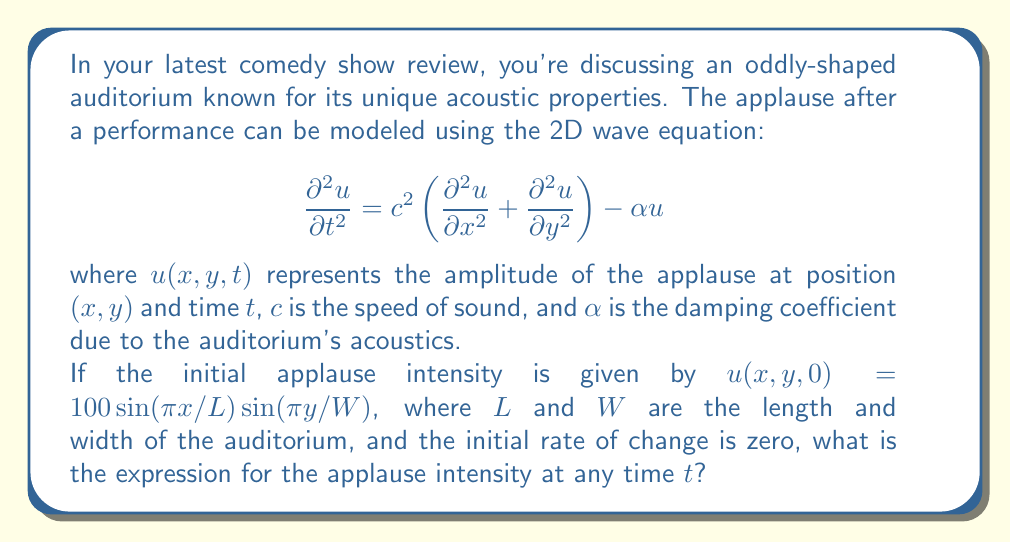Could you help me with this problem? To solve this problem, we'll follow these steps:

1) The given wave equation is a damped wave equation due to the $-\alpha u$ term.

2) We need to find a solution that satisfies the initial conditions:
   $u(x,y,0) = 100 \sin(\pi x/L) \sin(\pi y/W)$
   $\frac{\partial u}{\partial t}(x,y,0) = 0$

3) The general solution for such a damped wave equation is of the form:
   $u(x,y,t) = X(x)Y(y)T(t)$

4) Substituting this into the wave equation and separating variables, we get:
   $$\frac{T''}{T} = c^2 \left(\frac{X''}{X} + \frac{Y''}{Y}\right) - \alpha = -\omega^2$$

   Where $\omega^2$ is a separation constant.

5) This leads to three separate equations:
   $X'' + k_x^2 X = 0$
   $Y'' + k_y^2 Y = 0$
   $T'' + (\omega^2 - \alpha)T = 0$

   Where $c^2(k_x^2 + k_y^2) = \omega^2$

6) Given the initial condition, we can deduce:
   $X(x) = \sin(\pi x/L)$, so $k_x = \pi/L$
   $Y(y) = \sin(\pi y/W)$, so $k_y = \pi/W$

7) Therefore, $\omega^2 = c^2\pi^2(\frac{1}{L^2} + \frac{1}{W^2})$

8) The solution for T(t) is:
   $T(t) = e^{-\alpha t/2}(A \cos(\beta t) + B \sin(\beta t))$
   Where $\beta = \sqrt{\omega^2 - \frac{\alpha^2}{4}}$

9) Using the initial conditions:
   $T(0) = 100$, so $A = 100$
   $T'(0) = 0$, so $B = \frac{\alpha}{2\beta} A = \frac{50\alpha}{\beta}$

10) Therefore, the complete solution is:
    $$u(x,y,t) = 100 e^{-\alpha t/2} \left(\cos(\beta t) + \frac{\alpha}{2\beta} \sin(\beta t)\right) \sin(\pi x/L) \sin(\pi y/W)$$
Answer: $100 e^{-\alpha t/2} (\cos(\beta t) + \frac{\alpha}{2\beta} \sin(\beta t)) \sin(\pi x/L) \sin(\pi y/W)$ 